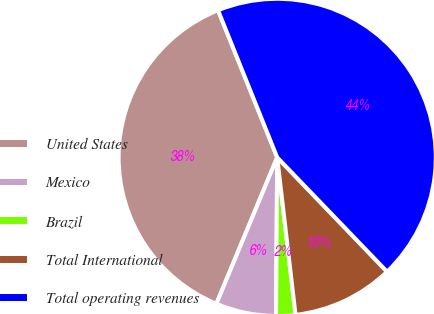Convert chart. <chart><loc_0><loc_0><loc_500><loc_500><pie_chart><fcel>United States<fcel>Mexico<fcel>Brazil<fcel>Total International<fcel>Total operating revenues<nl><fcel>37.65%<fcel>6.15%<fcel>1.96%<fcel>10.34%<fcel>43.9%<nl></chart> 